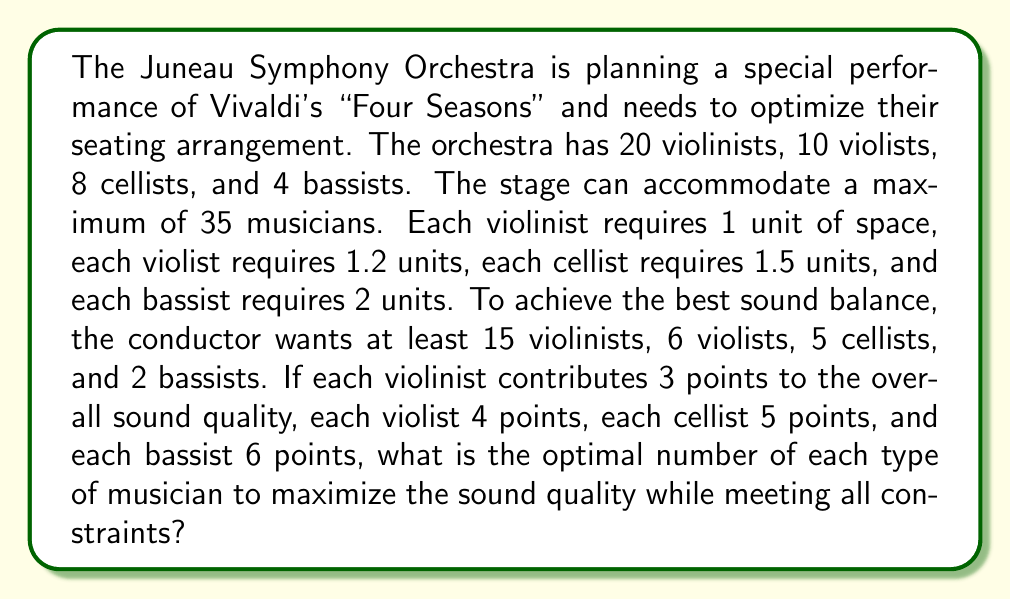Show me your answer to this math problem. Let's approach this problem using linear programming:

1. Define variables:
   $x_1$ = number of violinists
   $x_2$ = number of violists
   $x_3$ = number of cellists
   $x_4$ = number of bassists

2. Objective function (maximize sound quality):
   $$\text{Maximize } Z = 3x_1 + 4x_2 + 5x_3 + 6x_4$$

3. Constraints:
   a) Maximum number of musicians: $x_1 + x_2 + x_3 + x_4 \leq 35$
   b) Space constraint: $1x_1 + 1.2x_2 + 1.5x_3 + 2x_4 \leq 35$
   c) Minimum number of each instrument:
      $x_1 \geq 15$
      $x_2 \geq 6$
      $x_3 \geq 5$
      $x_4 \geq 2$
   d) Maximum available musicians:
      $x_1 \leq 20$
      $x_2 \leq 10$
      $x_3 \leq 8$
      $x_4 \leq 4$

4. Solve using the simplex method or a linear programming solver.

5. The optimal solution is:
   $x_1 = 18$ (violinists)
   $x_2 = 6$ (violists)
   $x_3 = 7$ (cellists)
   $x_4 = 4$ (bassists)

This solution maximizes the sound quality score at 119 points while satisfying all constraints.
Answer: 18 violinists, 6 violists, 7 cellists, 4 bassists 